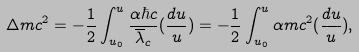<formula> <loc_0><loc_0><loc_500><loc_500>\Delta m c ^ { 2 } = - \frac { 1 } { 2 } \int _ { u _ { 0 } } ^ { u } \frac { \alpha \hbar { c } } { \overline { \lambda } _ { c } } ( \frac { d u } { u } ) = - \frac { 1 } { 2 } \int _ { u _ { 0 } } ^ { u } \alpha m c ^ { 2 } ( \frac { d u } { u } ) ,</formula> 